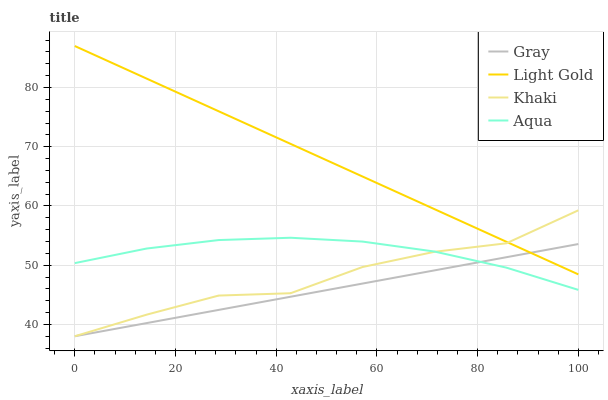Does Gray have the minimum area under the curve?
Answer yes or no. Yes. Does Light Gold have the maximum area under the curve?
Answer yes or no. Yes. Does Khaki have the minimum area under the curve?
Answer yes or no. No. Does Khaki have the maximum area under the curve?
Answer yes or no. No. Is Gray the smoothest?
Answer yes or no. Yes. Is Khaki the roughest?
Answer yes or no. Yes. Is Khaki the smoothest?
Answer yes or no. No. Is Gray the roughest?
Answer yes or no. No. Does Light Gold have the lowest value?
Answer yes or no. No. Does Light Gold have the highest value?
Answer yes or no. Yes. Does Khaki have the highest value?
Answer yes or no. No. Is Aqua less than Light Gold?
Answer yes or no. Yes. Is Light Gold greater than Aqua?
Answer yes or no. Yes. Does Khaki intersect Gray?
Answer yes or no. Yes. Is Khaki less than Gray?
Answer yes or no. No. Is Khaki greater than Gray?
Answer yes or no. No. Does Aqua intersect Light Gold?
Answer yes or no. No. 